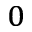Convert formula to latex. <formula><loc_0><loc_0><loc_500><loc_500>_ { 0 }</formula> 